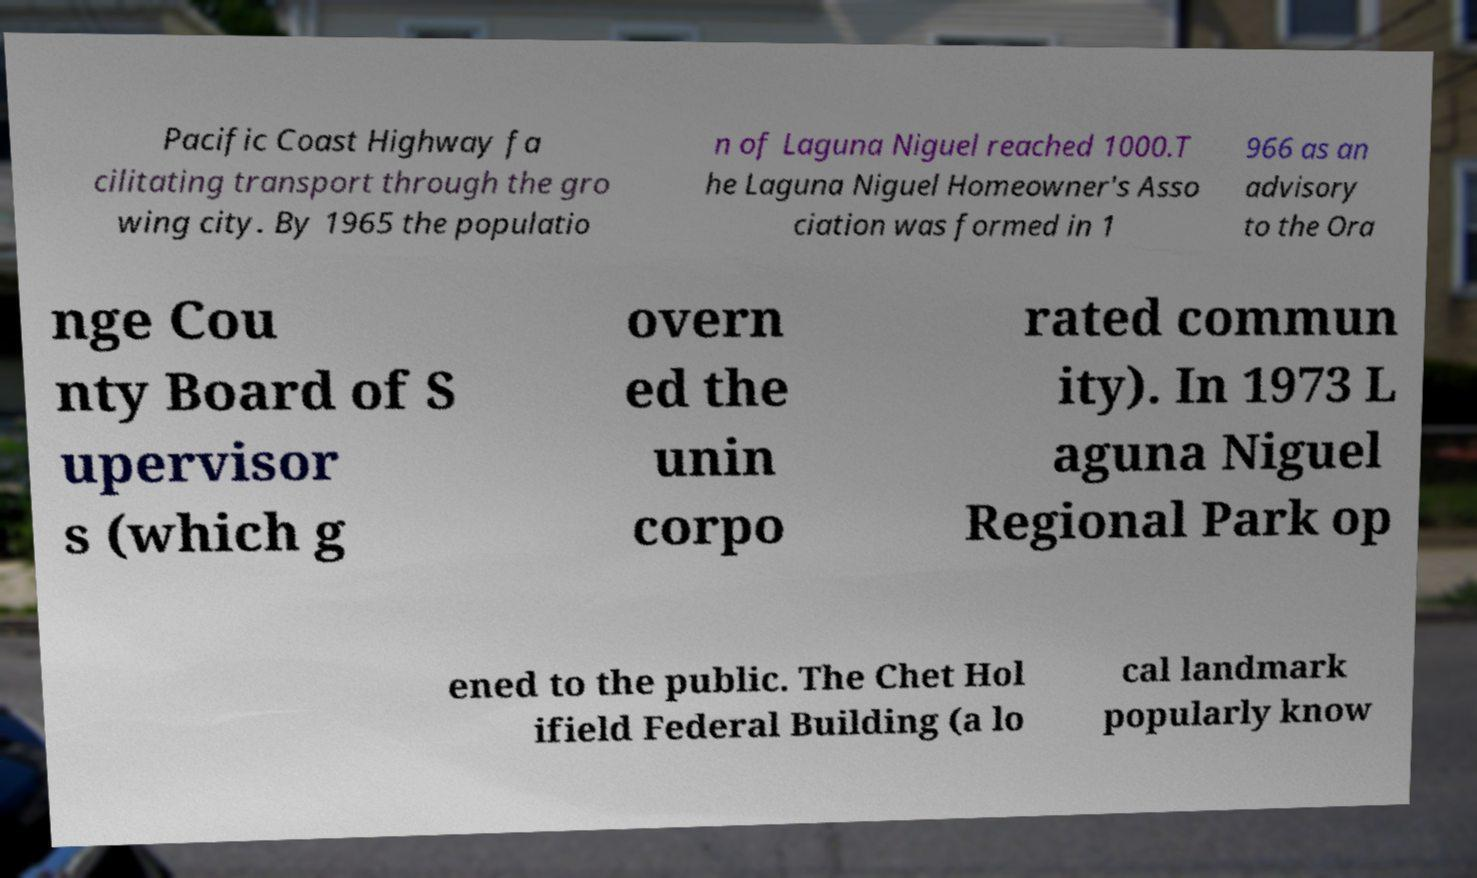Could you assist in decoding the text presented in this image and type it out clearly? Pacific Coast Highway fa cilitating transport through the gro wing city. By 1965 the populatio n of Laguna Niguel reached 1000.T he Laguna Niguel Homeowner's Asso ciation was formed in 1 966 as an advisory to the Ora nge Cou nty Board of S upervisor s (which g overn ed the unin corpo rated commun ity). In 1973 L aguna Niguel Regional Park op ened to the public. The Chet Hol ifield Federal Building (a lo cal landmark popularly know 